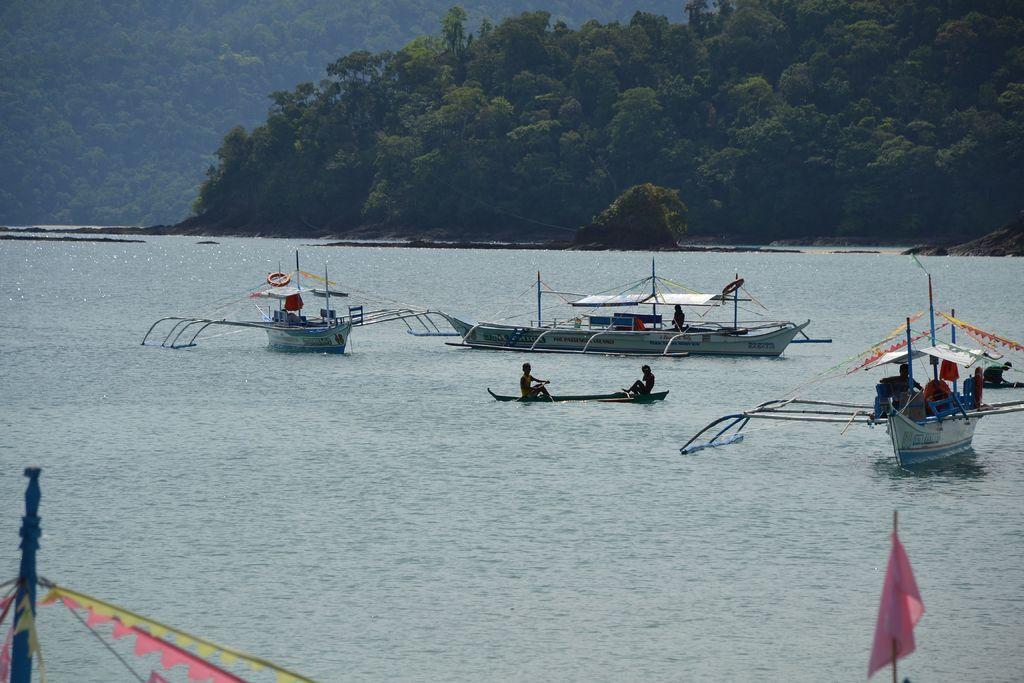Please provide a concise description of this image. In this picture we can see a few boats, some people and other objects are visible on these boats. We can see a tube on the water. There are some colorful objects visible at the bottom of the picture. We can see a few trees in the background. 